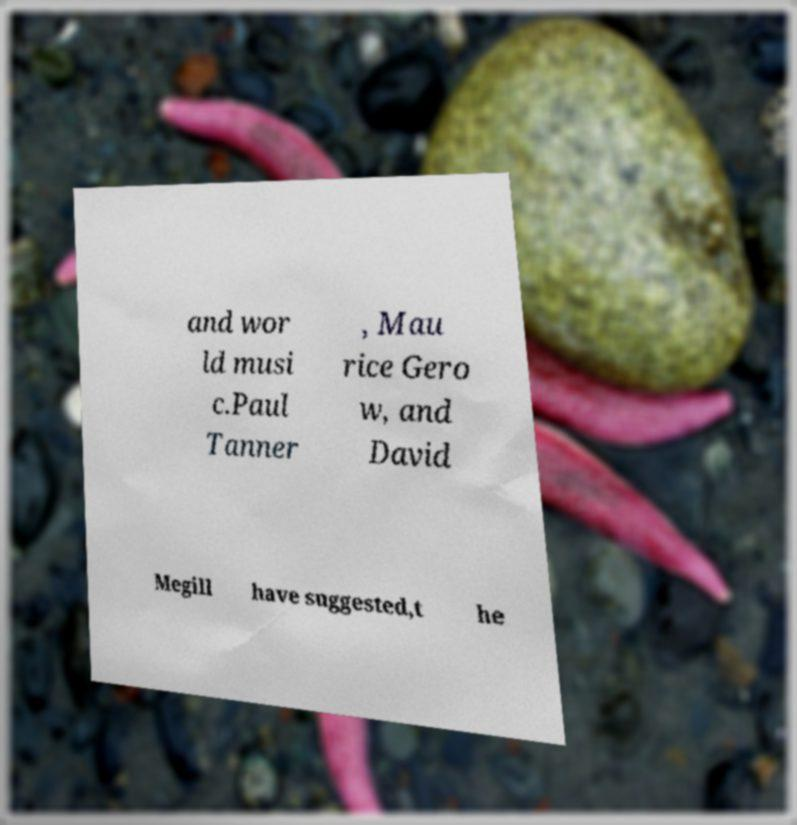Could you extract and type out the text from this image? and wor ld musi c.Paul Tanner , Mau rice Gero w, and David Megill have suggested,t he 